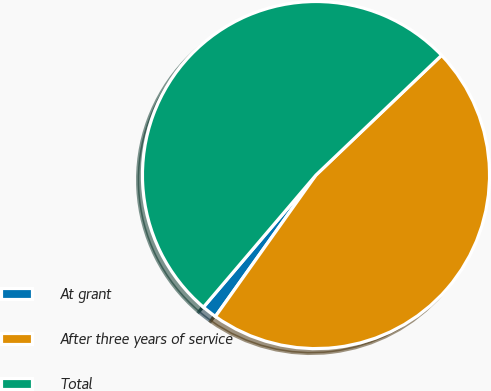<chart> <loc_0><loc_0><loc_500><loc_500><pie_chart><fcel>At grant<fcel>After three years of service<fcel>Total<nl><fcel>1.39%<fcel>46.96%<fcel>51.65%<nl></chart> 